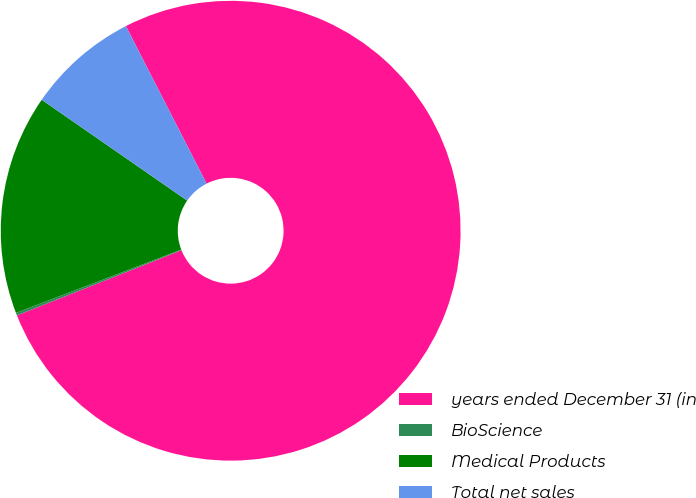Convert chart to OTSL. <chart><loc_0><loc_0><loc_500><loc_500><pie_chart><fcel>years ended December 31 (in<fcel>BioScience<fcel>Medical Products<fcel>Total net sales<nl><fcel>76.53%<fcel>0.19%<fcel>15.46%<fcel>7.82%<nl></chart> 